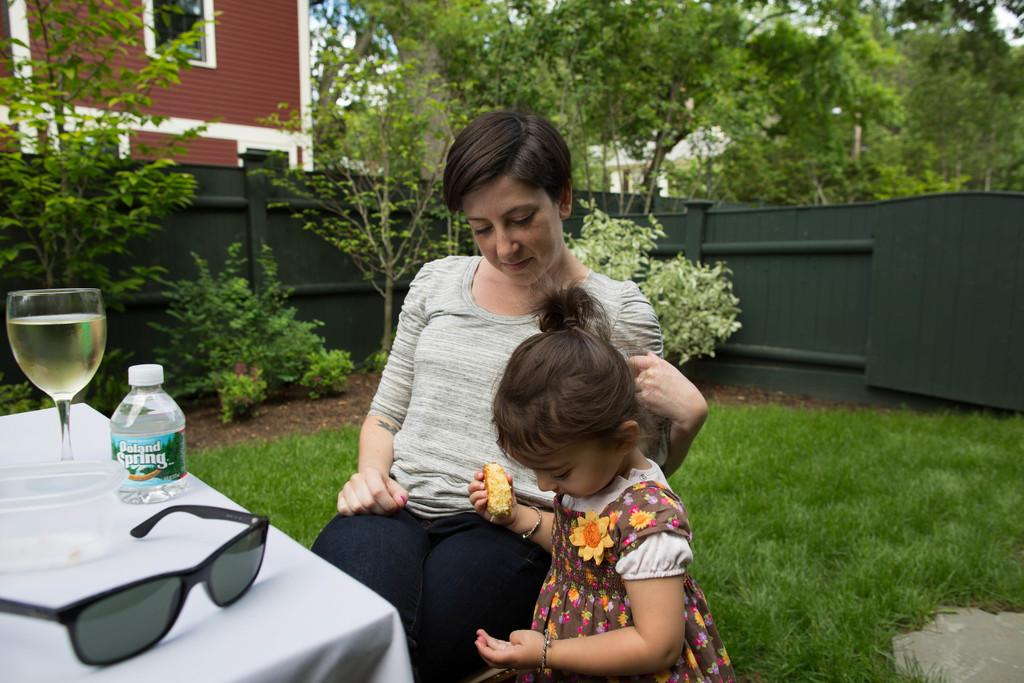Who is present in the image? There is a lady and a small girl in the image. What are the lady and the small girl doing in the image? The lady and the small girl are sitting on a table. Where was the image taken? The image was taken outside a house. What type of test is being conducted on the table in the image? There is no test being conducted in the image; the lady and the small girl are simply sitting on a table. 